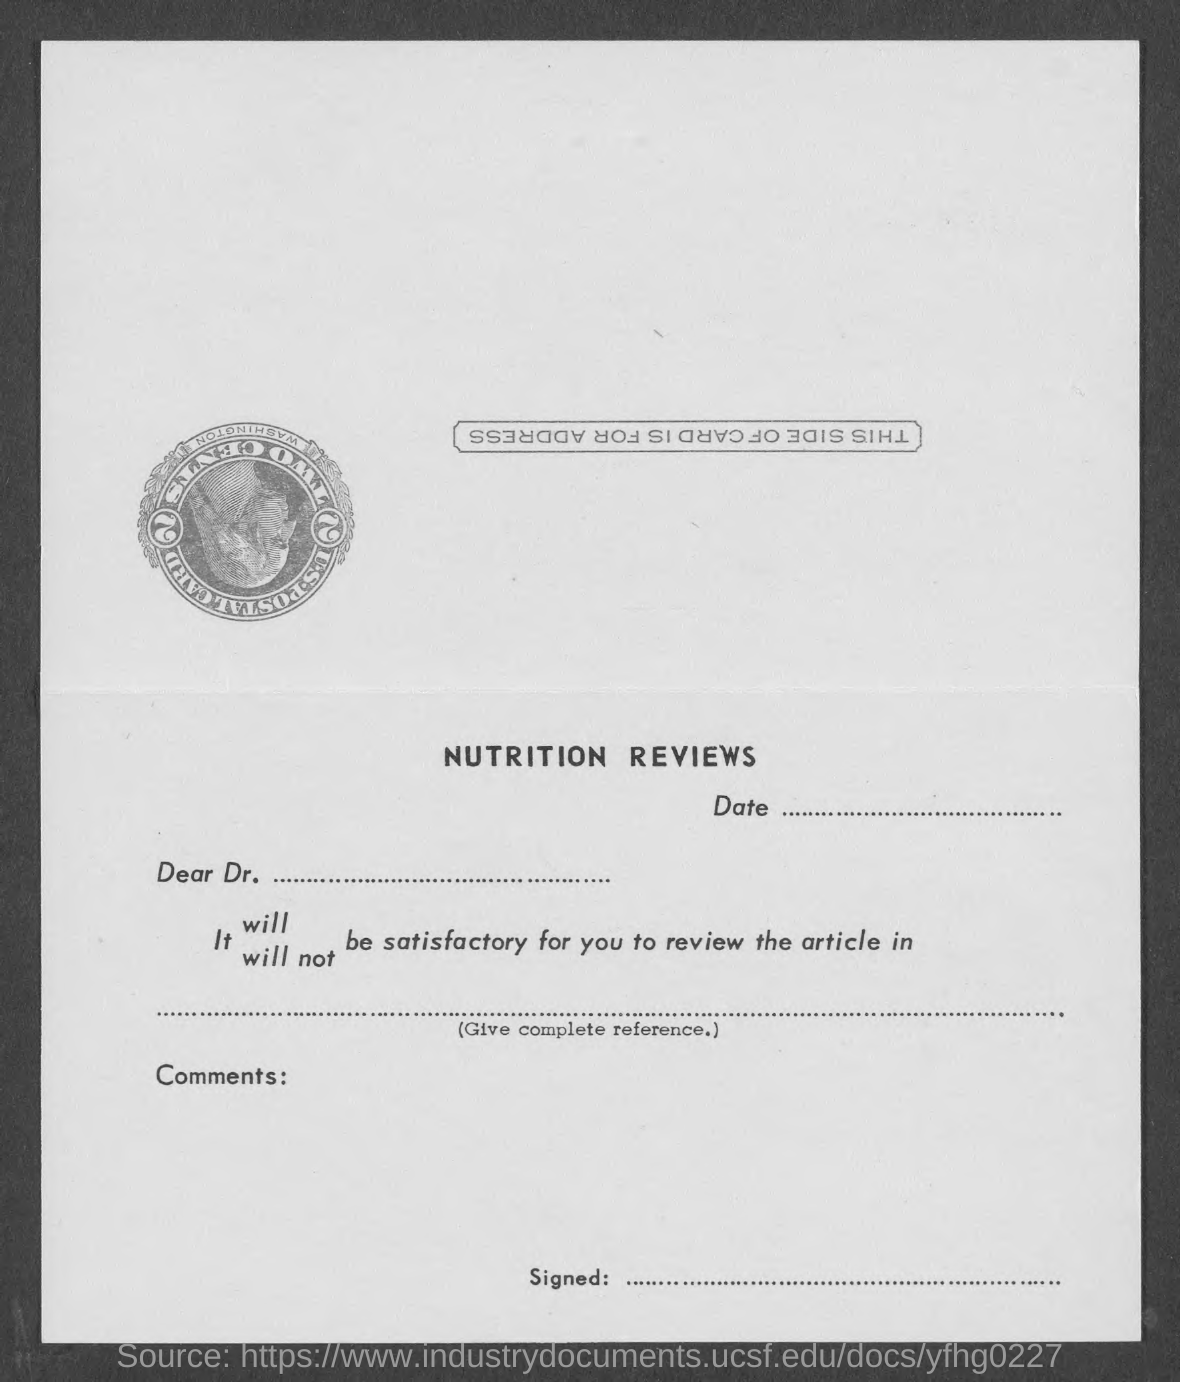What is the headding?
Offer a terse response. NUTRITION REVIEWS. What is the salutation of this letter?
Ensure brevity in your answer.  Dear Dr. ..... 